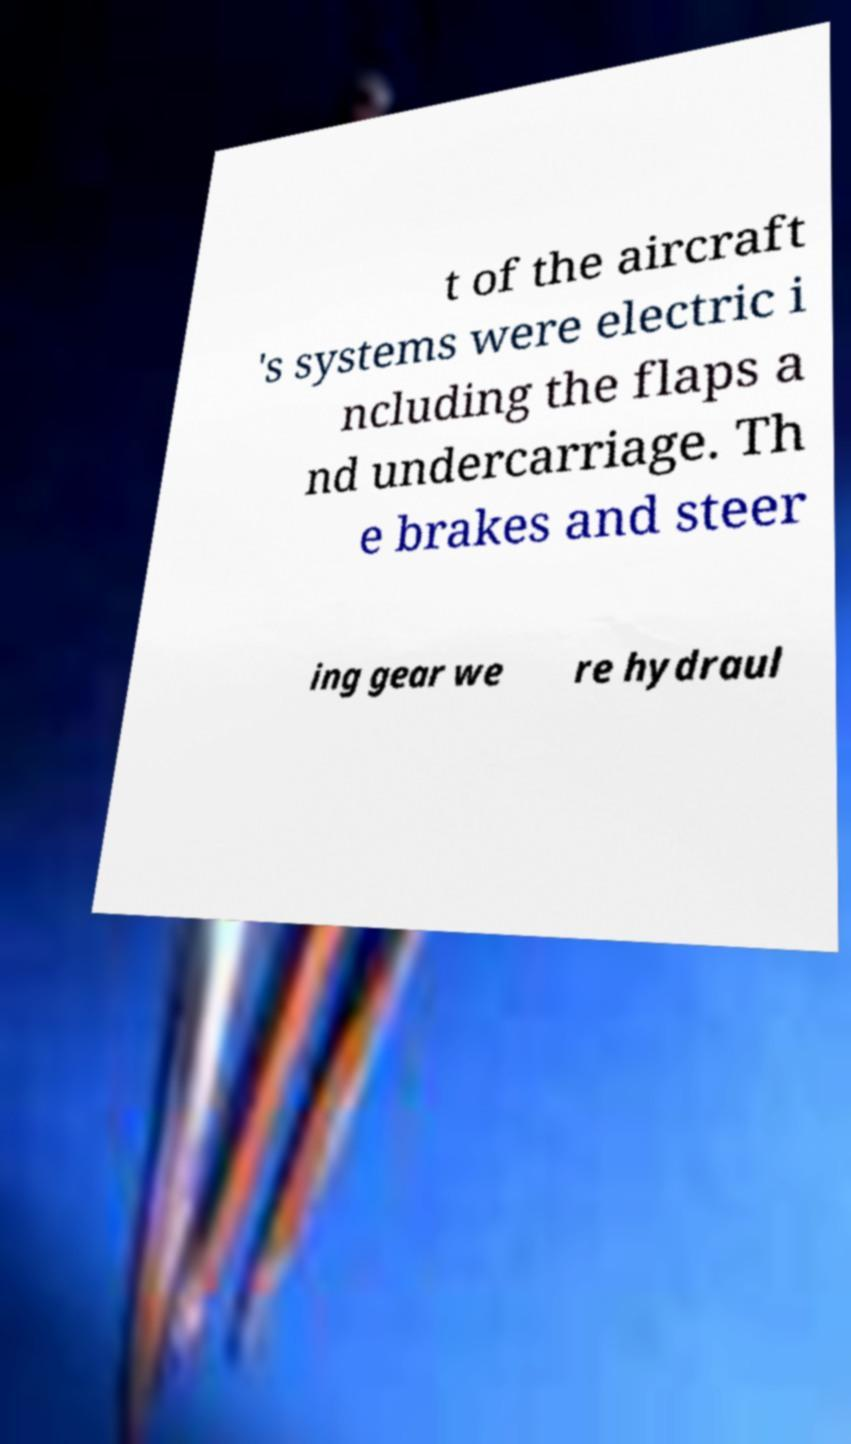Please identify and transcribe the text found in this image. t of the aircraft 's systems were electric i ncluding the flaps a nd undercarriage. Th e brakes and steer ing gear we re hydraul 